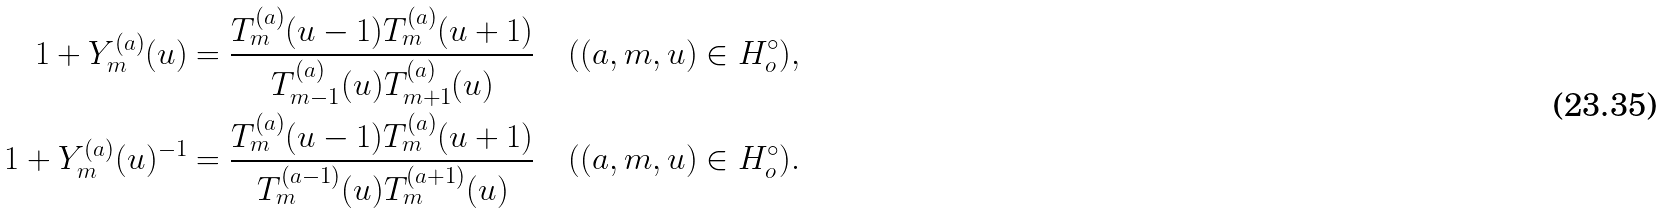Convert formula to latex. <formula><loc_0><loc_0><loc_500><loc_500>1 + Y ^ { ( a ) } _ { m } ( u ) & = \frac { T ^ { ( a ) } _ { m } ( u - 1 ) T ^ { ( a ) } _ { m } ( u + 1 ) } { T ^ { ( a ) } _ { m - 1 } ( u ) T ^ { ( a ) } _ { m + 1 } ( u ) } \quad ( ( a , m , u ) \in H ^ { \circ } _ { o } ) , \\ 1 + Y ^ { ( a ) } _ { m } ( u ) ^ { - 1 } & = \frac { T ^ { ( a ) } _ { m } ( u - 1 ) T ^ { ( a ) } _ { m } ( u + 1 ) } { T ^ { ( a - 1 ) } _ { m } ( u ) T ^ { ( a + 1 ) } _ { m } ( u ) } \quad ( ( a , m , u ) \in H ^ { \circ } _ { o } ) .</formula> 